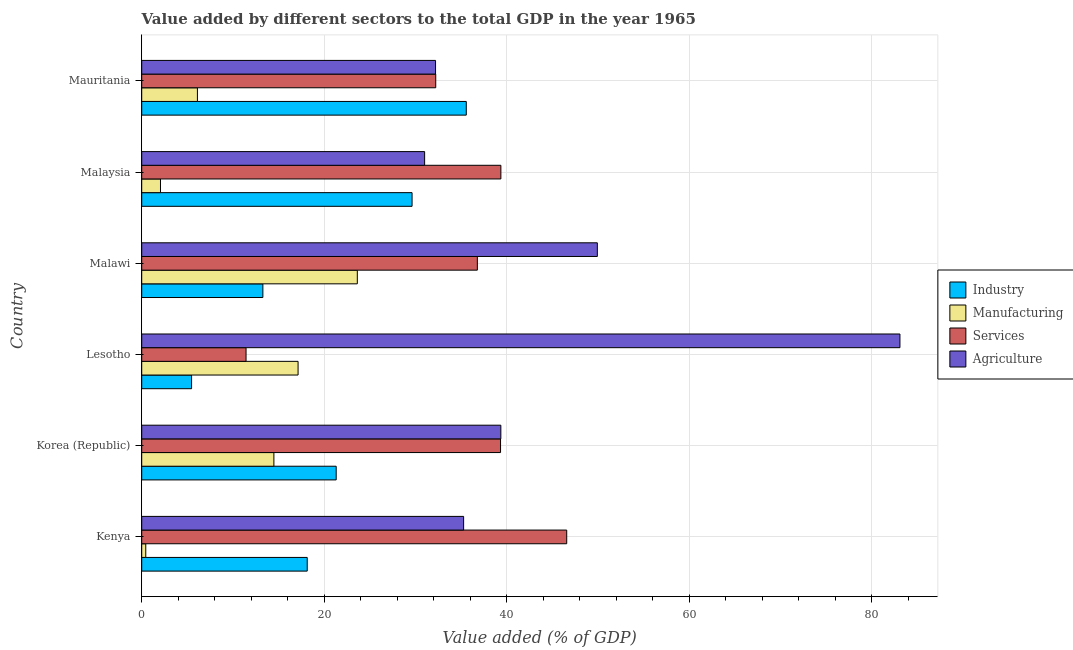How many groups of bars are there?
Offer a terse response. 6. Are the number of bars on each tick of the Y-axis equal?
Ensure brevity in your answer.  Yes. What is the label of the 5th group of bars from the top?
Keep it short and to the point. Korea (Republic). What is the value added by services sector in Mauritania?
Make the answer very short. 32.22. Across all countries, what is the maximum value added by manufacturing sector?
Provide a short and direct response. 23.63. Across all countries, what is the minimum value added by industrial sector?
Your answer should be very brief. 5.46. In which country was the value added by industrial sector maximum?
Offer a very short reply. Mauritania. In which country was the value added by agricultural sector minimum?
Give a very brief answer. Malaysia. What is the total value added by services sector in the graph?
Make the answer very short. 205.71. What is the difference between the value added by manufacturing sector in Korea (Republic) and that in Mauritania?
Give a very brief answer. 8.38. What is the difference between the value added by agricultural sector in Korea (Republic) and the value added by industrial sector in Malawi?
Ensure brevity in your answer.  26.08. What is the average value added by agricultural sector per country?
Your answer should be very brief. 45.15. What is the difference between the value added by industrial sector and value added by manufacturing sector in Malawi?
Give a very brief answer. -10.35. In how many countries, is the value added by industrial sector greater than 64 %?
Your answer should be very brief. 0. What is the ratio of the value added by services sector in Korea (Republic) to that in Lesotho?
Offer a terse response. 3.44. Is the value added by manufacturing sector in Lesotho less than that in Mauritania?
Offer a terse response. No. What is the difference between the highest and the second highest value added by manufacturing sector?
Provide a short and direct response. 6.49. What is the difference between the highest and the lowest value added by agricultural sector?
Ensure brevity in your answer.  52.1. In how many countries, is the value added by agricultural sector greater than the average value added by agricultural sector taken over all countries?
Provide a succinct answer. 2. Is it the case that in every country, the sum of the value added by agricultural sector and value added by manufacturing sector is greater than the sum of value added by industrial sector and value added by services sector?
Offer a terse response. No. What does the 3rd bar from the top in Korea (Republic) represents?
Give a very brief answer. Manufacturing. What does the 2nd bar from the bottom in Malawi represents?
Provide a succinct answer. Manufacturing. What is the difference between two consecutive major ticks on the X-axis?
Keep it short and to the point. 20. Does the graph contain grids?
Offer a very short reply. Yes. Where does the legend appear in the graph?
Provide a short and direct response. Center right. How many legend labels are there?
Keep it short and to the point. 4. How are the legend labels stacked?
Offer a very short reply. Vertical. What is the title of the graph?
Provide a succinct answer. Value added by different sectors to the total GDP in the year 1965. Does "Argument" appear as one of the legend labels in the graph?
Your answer should be very brief. No. What is the label or title of the X-axis?
Give a very brief answer. Value added (% of GDP). What is the Value added (% of GDP) of Industry in Kenya?
Make the answer very short. 18.14. What is the Value added (% of GDP) of Manufacturing in Kenya?
Give a very brief answer. 0.44. What is the Value added (% of GDP) in Services in Kenya?
Your response must be concise. 46.58. What is the Value added (% of GDP) in Agriculture in Kenya?
Keep it short and to the point. 35.28. What is the Value added (% of GDP) of Industry in Korea (Republic)?
Your answer should be very brief. 21.31. What is the Value added (% of GDP) in Manufacturing in Korea (Republic)?
Your answer should be very brief. 14.49. What is the Value added (% of GDP) in Services in Korea (Republic)?
Your response must be concise. 39.33. What is the Value added (% of GDP) of Agriculture in Korea (Republic)?
Your response must be concise. 39.36. What is the Value added (% of GDP) in Industry in Lesotho?
Provide a short and direct response. 5.46. What is the Value added (% of GDP) in Manufacturing in Lesotho?
Your answer should be compact. 17.14. What is the Value added (% of GDP) in Services in Lesotho?
Provide a short and direct response. 11.43. What is the Value added (% of GDP) of Agriculture in Lesotho?
Your answer should be very brief. 83.1. What is the Value added (% of GDP) of Industry in Malawi?
Provide a succinct answer. 13.28. What is the Value added (% of GDP) of Manufacturing in Malawi?
Provide a succinct answer. 23.63. What is the Value added (% of GDP) of Services in Malawi?
Give a very brief answer. 36.79. What is the Value added (% of GDP) in Agriculture in Malawi?
Your answer should be very brief. 49.94. What is the Value added (% of GDP) in Industry in Malaysia?
Ensure brevity in your answer.  29.63. What is the Value added (% of GDP) of Manufacturing in Malaysia?
Provide a succinct answer. 2.06. What is the Value added (% of GDP) in Services in Malaysia?
Provide a short and direct response. 39.36. What is the Value added (% of GDP) of Agriculture in Malaysia?
Provide a succinct answer. 31.01. What is the Value added (% of GDP) of Industry in Mauritania?
Your response must be concise. 35.57. What is the Value added (% of GDP) in Manufacturing in Mauritania?
Keep it short and to the point. 6.11. What is the Value added (% of GDP) in Services in Mauritania?
Your response must be concise. 32.22. What is the Value added (% of GDP) of Agriculture in Mauritania?
Your response must be concise. 32.2. Across all countries, what is the maximum Value added (% of GDP) in Industry?
Give a very brief answer. 35.57. Across all countries, what is the maximum Value added (% of GDP) in Manufacturing?
Provide a succinct answer. 23.63. Across all countries, what is the maximum Value added (% of GDP) of Services?
Your answer should be very brief. 46.58. Across all countries, what is the maximum Value added (% of GDP) in Agriculture?
Your response must be concise. 83.1. Across all countries, what is the minimum Value added (% of GDP) in Industry?
Make the answer very short. 5.46. Across all countries, what is the minimum Value added (% of GDP) in Manufacturing?
Make the answer very short. 0.44. Across all countries, what is the minimum Value added (% of GDP) of Services?
Your response must be concise. 11.43. Across all countries, what is the minimum Value added (% of GDP) of Agriculture?
Provide a succinct answer. 31.01. What is the total Value added (% of GDP) of Industry in the graph?
Give a very brief answer. 123.4. What is the total Value added (% of GDP) of Manufacturing in the graph?
Keep it short and to the point. 63.85. What is the total Value added (% of GDP) in Services in the graph?
Your answer should be very brief. 205.71. What is the total Value added (% of GDP) in Agriculture in the graph?
Your answer should be compact. 270.89. What is the difference between the Value added (% of GDP) in Industry in Kenya and that in Korea (Republic)?
Provide a succinct answer. -3.17. What is the difference between the Value added (% of GDP) in Manufacturing in Kenya and that in Korea (Republic)?
Your answer should be very brief. -14.04. What is the difference between the Value added (% of GDP) of Services in Kenya and that in Korea (Republic)?
Your response must be concise. 7.25. What is the difference between the Value added (% of GDP) of Agriculture in Kenya and that in Korea (Republic)?
Ensure brevity in your answer.  -4.08. What is the difference between the Value added (% of GDP) in Industry in Kenya and that in Lesotho?
Provide a short and direct response. 12.67. What is the difference between the Value added (% of GDP) of Manufacturing in Kenya and that in Lesotho?
Offer a very short reply. -16.69. What is the difference between the Value added (% of GDP) in Services in Kenya and that in Lesotho?
Provide a succinct answer. 35.15. What is the difference between the Value added (% of GDP) of Agriculture in Kenya and that in Lesotho?
Your answer should be compact. -47.82. What is the difference between the Value added (% of GDP) of Industry in Kenya and that in Malawi?
Your answer should be compact. 4.86. What is the difference between the Value added (% of GDP) in Manufacturing in Kenya and that in Malawi?
Make the answer very short. -23.19. What is the difference between the Value added (% of GDP) of Services in Kenya and that in Malawi?
Provide a short and direct response. 9.79. What is the difference between the Value added (% of GDP) in Agriculture in Kenya and that in Malawi?
Give a very brief answer. -14.65. What is the difference between the Value added (% of GDP) in Industry in Kenya and that in Malaysia?
Give a very brief answer. -11.49. What is the difference between the Value added (% of GDP) in Manufacturing in Kenya and that in Malaysia?
Your answer should be very brief. -1.61. What is the difference between the Value added (% of GDP) in Services in Kenya and that in Malaysia?
Give a very brief answer. 7.22. What is the difference between the Value added (% of GDP) in Agriculture in Kenya and that in Malaysia?
Provide a succinct answer. 4.27. What is the difference between the Value added (% of GDP) of Industry in Kenya and that in Mauritania?
Offer a terse response. -17.43. What is the difference between the Value added (% of GDP) in Manufacturing in Kenya and that in Mauritania?
Offer a terse response. -5.66. What is the difference between the Value added (% of GDP) in Services in Kenya and that in Mauritania?
Provide a succinct answer. 14.36. What is the difference between the Value added (% of GDP) in Agriculture in Kenya and that in Mauritania?
Keep it short and to the point. 3.08. What is the difference between the Value added (% of GDP) of Industry in Korea (Republic) and that in Lesotho?
Your response must be concise. 15.85. What is the difference between the Value added (% of GDP) in Manufacturing in Korea (Republic) and that in Lesotho?
Offer a terse response. -2.65. What is the difference between the Value added (% of GDP) of Services in Korea (Republic) and that in Lesotho?
Your answer should be very brief. 27.89. What is the difference between the Value added (% of GDP) of Agriculture in Korea (Republic) and that in Lesotho?
Ensure brevity in your answer.  -43.74. What is the difference between the Value added (% of GDP) of Industry in Korea (Republic) and that in Malawi?
Provide a succinct answer. 8.03. What is the difference between the Value added (% of GDP) in Manufacturing in Korea (Republic) and that in Malawi?
Keep it short and to the point. -9.14. What is the difference between the Value added (% of GDP) in Services in Korea (Republic) and that in Malawi?
Offer a terse response. 2.54. What is the difference between the Value added (% of GDP) in Agriculture in Korea (Republic) and that in Malawi?
Your answer should be compact. -10.58. What is the difference between the Value added (% of GDP) of Industry in Korea (Republic) and that in Malaysia?
Make the answer very short. -8.32. What is the difference between the Value added (% of GDP) of Manufacturing in Korea (Republic) and that in Malaysia?
Your answer should be compact. 12.43. What is the difference between the Value added (% of GDP) in Services in Korea (Republic) and that in Malaysia?
Your response must be concise. -0.04. What is the difference between the Value added (% of GDP) of Agriculture in Korea (Republic) and that in Malaysia?
Offer a terse response. 8.35. What is the difference between the Value added (% of GDP) in Industry in Korea (Republic) and that in Mauritania?
Give a very brief answer. -14.26. What is the difference between the Value added (% of GDP) of Manufacturing in Korea (Republic) and that in Mauritania?
Provide a succinct answer. 8.38. What is the difference between the Value added (% of GDP) of Services in Korea (Republic) and that in Mauritania?
Ensure brevity in your answer.  7.1. What is the difference between the Value added (% of GDP) in Agriculture in Korea (Republic) and that in Mauritania?
Offer a terse response. 7.16. What is the difference between the Value added (% of GDP) in Industry in Lesotho and that in Malawi?
Your response must be concise. -7.81. What is the difference between the Value added (% of GDP) of Manufacturing in Lesotho and that in Malawi?
Make the answer very short. -6.49. What is the difference between the Value added (% of GDP) of Services in Lesotho and that in Malawi?
Your answer should be compact. -25.35. What is the difference between the Value added (% of GDP) in Agriculture in Lesotho and that in Malawi?
Keep it short and to the point. 33.17. What is the difference between the Value added (% of GDP) in Industry in Lesotho and that in Malaysia?
Keep it short and to the point. -24.17. What is the difference between the Value added (% of GDP) of Manufacturing in Lesotho and that in Malaysia?
Provide a succinct answer. 15.08. What is the difference between the Value added (% of GDP) of Services in Lesotho and that in Malaysia?
Provide a short and direct response. -27.93. What is the difference between the Value added (% of GDP) in Agriculture in Lesotho and that in Malaysia?
Your answer should be compact. 52.1. What is the difference between the Value added (% of GDP) of Industry in Lesotho and that in Mauritania?
Offer a very short reply. -30.11. What is the difference between the Value added (% of GDP) of Manufacturing in Lesotho and that in Mauritania?
Provide a succinct answer. 11.03. What is the difference between the Value added (% of GDP) in Services in Lesotho and that in Mauritania?
Keep it short and to the point. -20.79. What is the difference between the Value added (% of GDP) of Agriculture in Lesotho and that in Mauritania?
Make the answer very short. 50.9. What is the difference between the Value added (% of GDP) in Industry in Malawi and that in Malaysia?
Give a very brief answer. -16.35. What is the difference between the Value added (% of GDP) of Manufacturing in Malawi and that in Malaysia?
Ensure brevity in your answer.  21.57. What is the difference between the Value added (% of GDP) of Services in Malawi and that in Malaysia?
Make the answer very short. -2.58. What is the difference between the Value added (% of GDP) in Agriculture in Malawi and that in Malaysia?
Provide a succinct answer. 18.93. What is the difference between the Value added (% of GDP) in Industry in Malawi and that in Mauritania?
Keep it short and to the point. -22.29. What is the difference between the Value added (% of GDP) in Manufacturing in Malawi and that in Mauritania?
Your answer should be very brief. 17.52. What is the difference between the Value added (% of GDP) in Services in Malawi and that in Mauritania?
Give a very brief answer. 4.56. What is the difference between the Value added (% of GDP) in Agriculture in Malawi and that in Mauritania?
Ensure brevity in your answer.  17.73. What is the difference between the Value added (% of GDP) of Industry in Malaysia and that in Mauritania?
Ensure brevity in your answer.  -5.94. What is the difference between the Value added (% of GDP) of Manufacturing in Malaysia and that in Mauritania?
Provide a succinct answer. -4.05. What is the difference between the Value added (% of GDP) in Services in Malaysia and that in Mauritania?
Ensure brevity in your answer.  7.14. What is the difference between the Value added (% of GDP) in Agriculture in Malaysia and that in Mauritania?
Provide a short and direct response. -1.2. What is the difference between the Value added (% of GDP) of Industry in Kenya and the Value added (% of GDP) of Manufacturing in Korea (Republic)?
Provide a succinct answer. 3.65. What is the difference between the Value added (% of GDP) of Industry in Kenya and the Value added (% of GDP) of Services in Korea (Republic)?
Provide a succinct answer. -21.19. What is the difference between the Value added (% of GDP) of Industry in Kenya and the Value added (% of GDP) of Agriculture in Korea (Republic)?
Your response must be concise. -21.22. What is the difference between the Value added (% of GDP) in Manufacturing in Kenya and the Value added (% of GDP) in Services in Korea (Republic)?
Offer a very short reply. -38.88. What is the difference between the Value added (% of GDP) of Manufacturing in Kenya and the Value added (% of GDP) of Agriculture in Korea (Republic)?
Keep it short and to the point. -38.92. What is the difference between the Value added (% of GDP) of Services in Kenya and the Value added (% of GDP) of Agriculture in Korea (Republic)?
Provide a short and direct response. 7.22. What is the difference between the Value added (% of GDP) of Industry in Kenya and the Value added (% of GDP) of Services in Lesotho?
Provide a succinct answer. 6.7. What is the difference between the Value added (% of GDP) in Industry in Kenya and the Value added (% of GDP) in Agriculture in Lesotho?
Provide a succinct answer. -64.96. What is the difference between the Value added (% of GDP) of Manufacturing in Kenya and the Value added (% of GDP) of Services in Lesotho?
Your response must be concise. -10.99. What is the difference between the Value added (% of GDP) of Manufacturing in Kenya and the Value added (% of GDP) of Agriculture in Lesotho?
Provide a succinct answer. -82.66. What is the difference between the Value added (% of GDP) in Services in Kenya and the Value added (% of GDP) in Agriculture in Lesotho?
Your answer should be compact. -36.52. What is the difference between the Value added (% of GDP) of Industry in Kenya and the Value added (% of GDP) of Manufacturing in Malawi?
Your answer should be very brief. -5.49. What is the difference between the Value added (% of GDP) in Industry in Kenya and the Value added (% of GDP) in Services in Malawi?
Provide a succinct answer. -18.65. What is the difference between the Value added (% of GDP) of Industry in Kenya and the Value added (% of GDP) of Agriculture in Malawi?
Offer a very short reply. -31.8. What is the difference between the Value added (% of GDP) in Manufacturing in Kenya and the Value added (% of GDP) in Services in Malawi?
Provide a short and direct response. -36.34. What is the difference between the Value added (% of GDP) of Manufacturing in Kenya and the Value added (% of GDP) of Agriculture in Malawi?
Make the answer very short. -49.49. What is the difference between the Value added (% of GDP) of Services in Kenya and the Value added (% of GDP) of Agriculture in Malawi?
Provide a succinct answer. -3.36. What is the difference between the Value added (% of GDP) in Industry in Kenya and the Value added (% of GDP) in Manufacturing in Malaysia?
Give a very brief answer. 16.08. What is the difference between the Value added (% of GDP) in Industry in Kenya and the Value added (% of GDP) in Services in Malaysia?
Offer a very short reply. -21.23. What is the difference between the Value added (% of GDP) of Industry in Kenya and the Value added (% of GDP) of Agriculture in Malaysia?
Give a very brief answer. -12.87. What is the difference between the Value added (% of GDP) of Manufacturing in Kenya and the Value added (% of GDP) of Services in Malaysia?
Offer a terse response. -38.92. What is the difference between the Value added (% of GDP) in Manufacturing in Kenya and the Value added (% of GDP) in Agriculture in Malaysia?
Offer a very short reply. -30.56. What is the difference between the Value added (% of GDP) of Services in Kenya and the Value added (% of GDP) of Agriculture in Malaysia?
Provide a succinct answer. 15.57. What is the difference between the Value added (% of GDP) of Industry in Kenya and the Value added (% of GDP) of Manufacturing in Mauritania?
Your response must be concise. 12.03. What is the difference between the Value added (% of GDP) in Industry in Kenya and the Value added (% of GDP) in Services in Mauritania?
Ensure brevity in your answer.  -14.09. What is the difference between the Value added (% of GDP) in Industry in Kenya and the Value added (% of GDP) in Agriculture in Mauritania?
Provide a succinct answer. -14.06. What is the difference between the Value added (% of GDP) of Manufacturing in Kenya and the Value added (% of GDP) of Services in Mauritania?
Offer a very short reply. -31.78. What is the difference between the Value added (% of GDP) of Manufacturing in Kenya and the Value added (% of GDP) of Agriculture in Mauritania?
Your response must be concise. -31.76. What is the difference between the Value added (% of GDP) of Services in Kenya and the Value added (% of GDP) of Agriculture in Mauritania?
Provide a succinct answer. 14.38. What is the difference between the Value added (% of GDP) in Industry in Korea (Republic) and the Value added (% of GDP) in Manufacturing in Lesotho?
Provide a short and direct response. 4.18. What is the difference between the Value added (% of GDP) in Industry in Korea (Republic) and the Value added (% of GDP) in Services in Lesotho?
Provide a short and direct response. 9.88. What is the difference between the Value added (% of GDP) in Industry in Korea (Republic) and the Value added (% of GDP) in Agriculture in Lesotho?
Provide a succinct answer. -61.79. What is the difference between the Value added (% of GDP) in Manufacturing in Korea (Republic) and the Value added (% of GDP) in Services in Lesotho?
Make the answer very short. 3.05. What is the difference between the Value added (% of GDP) of Manufacturing in Korea (Republic) and the Value added (% of GDP) of Agriculture in Lesotho?
Provide a short and direct response. -68.62. What is the difference between the Value added (% of GDP) of Services in Korea (Republic) and the Value added (% of GDP) of Agriculture in Lesotho?
Your response must be concise. -43.77. What is the difference between the Value added (% of GDP) of Industry in Korea (Republic) and the Value added (% of GDP) of Manufacturing in Malawi?
Offer a terse response. -2.32. What is the difference between the Value added (% of GDP) in Industry in Korea (Republic) and the Value added (% of GDP) in Services in Malawi?
Make the answer very short. -15.47. What is the difference between the Value added (% of GDP) in Industry in Korea (Republic) and the Value added (% of GDP) in Agriculture in Malawi?
Ensure brevity in your answer.  -28.62. What is the difference between the Value added (% of GDP) in Manufacturing in Korea (Republic) and the Value added (% of GDP) in Services in Malawi?
Your answer should be very brief. -22.3. What is the difference between the Value added (% of GDP) of Manufacturing in Korea (Republic) and the Value added (% of GDP) of Agriculture in Malawi?
Provide a short and direct response. -35.45. What is the difference between the Value added (% of GDP) in Services in Korea (Republic) and the Value added (% of GDP) in Agriculture in Malawi?
Provide a succinct answer. -10.61. What is the difference between the Value added (% of GDP) in Industry in Korea (Republic) and the Value added (% of GDP) in Manufacturing in Malaysia?
Ensure brevity in your answer.  19.26. What is the difference between the Value added (% of GDP) in Industry in Korea (Republic) and the Value added (% of GDP) in Services in Malaysia?
Your answer should be very brief. -18.05. What is the difference between the Value added (% of GDP) of Industry in Korea (Republic) and the Value added (% of GDP) of Agriculture in Malaysia?
Provide a succinct answer. -9.69. What is the difference between the Value added (% of GDP) of Manufacturing in Korea (Republic) and the Value added (% of GDP) of Services in Malaysia?
Your response must be concise. -24.88. What is the difference between the Value added (% of GDP) in Manufacturing in Korea (Republic) and the Value added (% of GDP) in Agriculture in Malaysia?
Make the answer very short. -16.52. What is the difference between the Value added (% of GDP) in Services in Korea (Republic) and the Value added (% of GDP) in Agriculture in Malaysia?
Ensure brevity in your answer.  8.32. What is the difference between the Value added (% of GDP) of Industry in Korea (Republic) and the Value added (% of GDP) of Manufacturing in Mauritania?
Ensure brevity in your answer.  15.21. What is the difference between the Value added (% of GDP) of Industry in Korea (Republic) and the Value added (% of GDP) of Services in Mauritania?
Your answer should be compact. -10.91. What is the difference between the Value added (% of GDP) of Industry in Korea (Republic) and the Value added (% of GDP) of Agriculture in Mauritania?
Give a very brief answer. -10.89. What is the difference between the Value added (% of GDP) of Manufacturing in Korea (Republic) and the Value added (% of GDP) of Services in Mauritania?
Offer a terse response. -17.74. What is the difference between the Value added (% of GDP) of Manufacturing in Korea (Republic) and the Value added (% of GDP) of Agriculture in Mauritania?
Offer a very short reply. -17.72. What is the difference between the Value added (% of GDP) of Services in Korea (Republic) and the Value added (% of GDP) of Agriculture in Mauritania?
Your answer should be very brief. 7.12. What is the difference between the Value added (% of GDP) in Industry in Lesotho and the Value added (% of GDP) in Manufacturing in Malawi?
Ensure brevity in your answer.  -18.16. What is the difference between the Value added (% of GDP) of Industry in Lesotho and the Value added (% of GDP) of Services in Malawi?
Provide a short and direct response. -31.32. What is the difference between the Value added (% of GDP) of Industry in Lesotho and the Value added (% of GDP) of Agriculture in Malawi?
Provide a short and direct response. -44.47. What is the difference between the Value added (% of GDP) of Manufacturing in Lesotho and the Value added (% of GDP) of Services in Malawi?
Offer a terse response. -19.65. What is the difference between the Value added (% of GDP) in Manufacturing in Lesotho and the Value added (% of GDP) in Agriculture in Malawi?
Provide a short and direct response. -32.8. What is the difference between the Value added (% of GDP) in Services in Lesotho and the Value added (% of GDP) in Agriculture in Malawi?
Provide a short and direct response. -38.5. What is the difference between the Value added (% of GDP) of Industry in Lesotho and the Value added (% of GDP) of Manufacturing in Malaysia?
Provide a short and direct response. 3.41. What is the difference between the Value added (% of GDP) in Industry in Lesotho and the Value added (% of GDP) in Services in Malaysia?
Ensure brevity in your answer.  -33.9. What is the difference between the Value added (% of GDP) in Industry in Lesotho and the Value added (% of GDP) in Agriculture in Malaysia?
Ensure brevity in your answer.  -25.54. What is the difference between the Value added (% of GDP) in Manufacturing in Lesotho and the Value added (% of GDP) in Services in Malaysia?
Keep it short and to the point. -22.23. What is the difference between the Value added (% of GDP) of Manufacturing in Lesotho and the Value added (% of GDP) of Agriculture in Malaysia?
Give a very brief answer. -13.87. What is the difference between the Value added (% of GDP) of Services in Lesotho and the Value added (% of GDP) of Agriculture in Malaysia?
Keep it short and to the point. -19.57. What is the difference between the Value added (% of GDP) of Industry in Lesotho and the Value added (% of GDP) of Manufacturing in Mauritania?
Your response must be concise. -0.64. What is the difference between the Value added (% of GDP) in Industry in Lesotho and the Value added (% of GDP) in Services in Mauritania?
Your answer should be compact. -26.76. What is the difference between the Value added (% of GDP) of Industry in Lesotho and the Value added (% of GDP) of Agriculture in Mauritania?
Your answer should be very brief. -26.74. What is the difference between the Value added (% of GDP) in Manufacturing in Lesotho and the Value added (% of GDP) in Services in Mauritania?
Offer a terse response. -15.09. What is the difference between the Value added (% of GDP) in Manufacturing in Lesotho and the Value added (% of GDP) in Agriculture in Mauritania?
Offer a terse response. -15.07. What is the difference between the Value added (% of GDP) in Services in Lesotho and the Value added (% of GDP) in Agriculture in Mauritania?
Your answer should be very brief. -20.77. What is the difference between the Value added (% of GDP) of Industry in Malawi and the Value added (% of GDP) of Manufacturing in Malaysia?
Your response must be concise. 11.22. What is the difference between the Value added (% of GDP) in Industry in Malawi and the Value added (% of GDP) in Services in Malaysia?
Your answer should be compact. -26.09. What is the difference between the Value added (% of GDP) in Industry in Malawi and the Value added (% of GDP) in Agriculture in Malaysia?
Give a very brief answer. -17.73. What is the difference between the Value added (% of GDP) in Manufacturing in Malawi and the Value added (% of GDP) in Services in Malaysia?
Provide a short and direct response. -15.74. What is the difference between the Value added (% of GDP) of Manufacturing in Malawi and the Value added (% of GDP) of Agriculture in Malaysia?
Offer a terse response. -7.38. What is the difference between the Value added (% of GDP) in Services in Malawi and the Value added (% of GDP) in Agriculture in Malaysia?
Provide a short and direct response. 5.78. What is the difference between the Value added (% of GDP) in Industry in Malawi and the Value added (% of GDP) in Manufacturing in Mauritania?
Make the answer very short. 7.17. What is the difference between the Value added (% of GDP) of Industry in Malawi and the Value added (% of GDP) of Services in Mauritania?
Your answer should be compact. -18.95. What is the difference between the Value added (% of GDP) of Industry in Malawi and the Value added (% of GDP) of Agriculture in Mauritania?
Offer a very short reply. -18.93. What is the difference between the Value added (% of GDP) in Manufacturing in Malawi and the Value added (% of GDP) in Services in Mauritania?
Make the answer very short. -8.6. What is the difference between the Value added (% of GDP) of Manufacturing in Malawi and the Value added (% of GDP) of Agriculture in Mauritania?
Your answer should be very brief. -8.58. What is the difference between the Value added (% of GDP) of Services in Malawi and the Value added (% of GDP) of Agriculture in Mauritania?
Offer a very short reply. 4.58. What is the difference between the Value added (% of GDP) of Industry in Malaysia and the Value added (% of GDP) of Manufacturing in Mauritania?
Your answer should be very brief. 23.52. What is the difference between the Value added (% of GDP) in Industry in Malaysia and the Value added (% of GDP) in Services in Mauritania?
Provide a short and direct response. -2.59. What is the difference between the Value added (% of GDP) of Industry in Malaysia and the Value added (% of GDP) of Agriculture in Mauritania?
Make the answer very short. -2.57. What is the difference between the Value added (% of GDP) in Manufacturing in Malaysia and the Value added (% of GDP) in Services in Mauritania?
Provide a succinct answer. -30.17. What is the difference between the Value added (% of GDP) in Manufacturing in Malaysia and the Value added (% of GDP) in Agriculture in Mauritania?
Ensure brevity in your answer.  -30.15. What is the difference between the Value added (% of GDP) of Services in Malaysia and the Value added (% of GDP) of Agriculture in Mauritania?
Offer a terse response. 7.16. What is the average Value added (% of GDP) of Industry per country?
Your answer should be very brief. 20.57. What is the average Value added (% of GDP) in Manufacturing per country?
Offer a terse response. 10.64. What is the average Value added (% of GDP) of Services per country?
Your answer should be compact. 34.29. What is the average Value added (% of GDP) of Agriculture per country?
Your answer should be compact. 45.15. What is the difference between the Value added (% of GDP) in Industry and Value added (% of GDP) in Manufacturing in Kenya?
Make the answer very short. 17.7. What is the difference between the Value added (% of GDP) in Industry and Value added (% of GDP) in Services in Kenya?
Offer a terse response. -28.44. What is the difference between the Value added (% of GDP) in Industry and Value added (% of GDP) in Agriculture in Kenya?
Keep it short and to the point. -17.14. What is the difference between the Value added (% of GDP) in Manufacturing and Value added (% of GDP) in Services in Kenya?
Offer a terse response. -46.14. What is the difference between the Value added (% of GDP) of Manufacturing and Value added (% of GDP) of Agriculture in Kenya?
Your answer should be compact. -34.84. What is the difference between the Value added (% of GDP) in Services and Value added (% of GDP) in Agriculture in Kenya?
Your answer should be compact. 11.3. What is the difference between the Value added (% of GDP) in Industry and Value added (% of GDP) in Manufacturing in Korea (Republic)?
Your answer should be very brief. 6.83. What is the difference between the Value added (% of GDP) of Industry and Value added (% of GDP) of Services in Korea (Republic)?
Offer a very short reply. -18.01. What is the difference between the Value added (% of GDP) in Industry and Value added (% of GDP) in Agriculture in Korea (Republic)?
Offer a terse response. -18.05. What is the difference between the Value added (% of GDP) of Manufacturing and Value added (% of GDP) of Services in Korea (Republic)?
Your answer should be very brief. -24.84. What is the difference between the Value added (% of GDP) of Manufacturing and Value added (% of GDP) of Agriculture in Korea (Republic)?
Make the answer very short. -24.87. What is the difference between the Value added (% of GDP) of Services and Value added (% of GDP) of Agriculture in Korea (Republic)?
Offer a terse response. -0.03. What is the difference between the Value added (% of GDP) in Industry and Value added (% of GDP) in Manufacturing in Lesotho?
Keep it short and to the point. -11.67. What is the difference between the Value added (% of GDP) in Industry and Value added (% of GDP) in Services in Lesotho?
Provide a succinct answer. -5.97. What is the difference between the Value added (% of GDP) in Industry and Value added (% of GDP) in Agriculture in Lesotho?
Your answer should be very brief. -77.64. What is the difference between the Value added (% of GDP) of Manufacturing and Value added (% of GDP) of Services in Lesotho?
Provide a short and direct response. 5.7. What is the difference between the Value added (% of GDP) of Manufacturing and Value added (% of GDP) of Agriculture in Lesotho?
Your answer should be very brief. -65.97. What is the difference between the Value added (% of GDP) of Services and Value added (% of GDP) of Agriculture in Lesotho?
Your answer should be very brief. -71.67. What is the difference between the Value added (% of GDP) of Industry and Value added (% of GDP) of Manufacturing in Malawi?
Offer a very short reply. -10.35. What is the difference between the Value added (% of GDP) of Industry and Value added (% of GDP) of Services in Malawi?
Your answer should be compact. -23.51. What is the difference between the Value added (% of GDP) of Industry and Value added (% of GDP) of Agriculture in Malawi?
Keep it short and to the point. -36.66. What is the difference between the Value added (% of GDP) in Manufacturing and Value added (% of GDP) in Services in Malawi?
Offer a terse response. -13.16. What is the difference between the Value added (% of GDP) of Manufacturing and Value added (% of GDP) of Agriculture in Malawi?
Keep it short and to the point. -26.31. What is the difference between the Value added (% of GDP) in Services and Value added (% of GDP) in Agriculture in Malawi?
Your response must be concise. -13.15. What is the difference between the Value added (% of GDP) in Industry and Value added (% of GDP) in Manufacturing in Malaysia?
Your answer should be very brief. 27.57. What is the difference between the Value added (% of GDP) in Industry and Value added (% of GDP) in Services in Malaysia?
Your response must be concise. -9.73. What is the difference between the Value added (% of GDP) in Industry and Value added (% of GDP) in Agriculture in Malaysia?
Provide a succinct answer. -1.38. What is the difference between the Value added (% of GDP) in Manufacturing and Value added (% of GDP) in Services in Malaysia?
Give a very brief answer. -37.31. What is the difference between the Value added (% of GDP) of Manufacturing and Value added (% of GDP) of Agriculture in Malaysia?
Ensure brevity in your answer.  -28.95. What is the difference between the Value added (% of GDP) in Services and Value added (% of GDP) in Agriculture in Malaysia?
Your answer should be very brief. 8.36. What is the difference between the Value added (% of GDP) in Industry and Value added (% of GDP) in Manufacturing in Mauritania?
Provide a succinct answer. 29.47. What is the difference between the Value added (% of GDP) of Industry and Value added (% of GDP) of Services in Mauritania?
Your answer should be very brief. 3.35. What is the difference between the Value added (% of GDP) in Industry and Value added (% of GDP) in Agriculture in Mauritania?
Provide a succinct answer. 3.37. What is the difference between the Value added (% of GDP) in Manufacturing and Value added (% of GDP) in Services in Mauritania?
Give a very brief answer. -26.12. What is the difference between the Value added (% of GDP) of Manufacturing and Value added (% of GDP) of Agriculture in Mauritania?
Provide a succinct answer. -26.1. What is the difference between the Value added (% of GDP) of Services and Value added (% of GDP) of Agriculture in Mauritania?
Your response must be concise. 0.02. What is the ratio of the Value added (% of GDP) in Industry in Kenya to that in Korea (Republic)?
Provide a succinct answer. 0.85. What is the ratio of the Value added (% of GDP) in Manufacturing in Kenya to that in Korea (Republic)?
Provide a succinct answer. 0.03. What is the ratio of the Value added (% of GDP) of Services in Kenya to that in Korea (Republic)?
Provide a succinct answer. 1.18. What is the ratio of the Value added (% of GDP) in Agriculture in Kenya to that in Korea (Republic)?
Provide a succinct answer. 0.9. What is the ratio of the Value added (% of GDP) of Industry in Kenya to that in Lesotho?
Your response must be concise. 3.32. What is the ratio of the Value added (% of GDP) in Manufacturing in Kenya to that in Lesotho?
Your answer should be very brief. 0.03. What is the ratio of the Value added (% of GDP) of Services in Kenya to that in Lesotho?
Offer a terse response. 4.07. What is the ratio of the Value added (% of GDP) of Agriculture in Kenya to that in Lesotho?
Offer a very short reply. 0.42. What is the ratio of the Value added (% of GDP) in Industry in Kenya to that in Malawi?
Your answer should be very brief. 1.37. What is the ratio of the Value added (% of GDP) in Manufacturing in Kenya to that in Malawi?
Your answer should be compact. 0.02. What is the ratio of the Value added (% of GDP) of Services in Kenya to that in Malawi?
Your answer should be compact. 1.27. What is the ratio of the Value added (% of GDP) in Agriculture in Kenya to that in Malawi?
Your answer should be very brief. 0.71. What is the ratio of the Value added (% of GDP) of Industry in Kenya to that in Malaysia?
Make the answer very short. 0.61. What is the ratio of the Value added (% of GDP) of Manufacturing in Kenya to that in Malaysia?
Ensure brevity in your answer.  0.22. What is the ratio of the Value added (% of GDP) in Services in Kenya to that in Malaysia?
Provide a short and direct response. 1.18. What is the ratio of the Value added (% of GDP) of Agriculture in Kenya to that in Malaysia?
Ensure brevity in your answer.  1.14. What is the ratio of the Value added (% of GDP) of Industry in Kenya to that in Mauritania?
Offer a terse response. 0.51. What is the ratio of the Value added (% of GDP) of Manufacturing in Kenya to that in Mauritania?
Make the answer very short. 0.07. What is the ratio of the Value added (% of GDP) in Services in Kenya to that in Mauritania?
Ensure brevity in your answer.  1.45. What is the ratio of the Value added (% of GDP) in Agriculture in Kenya to that in Mauritania?
Make the answer very short. 1.1. What is the ratio of the Value added (% of GDP) of Industry in Korea (Republic) to that in Lesotho?
Make the answer very short. 3.9. What is the ratio of the Value added (% of GDP) in Manufacturing in Korea (Republic) to that in Lesotho?
Your response must be concise. 0.85. What is the ratio of the Value added (% of GDP) in Services in Korea (Republic) to that in Lesotho?
Make the answer very short. 3.44. What is the ratio of the Value added (% of GDP) in Agriculture in Korea (Republic) to that in Lesotho?
Keep it short and to the point. 0.47. What is the ratio of the Value added (% of GDP) of Industry in Korea (Republic) to that in Malawi?
Make the answer very short. 1.61. What is the ratio of the Value added (% of GDP) of Manufacturing in Korea (Republic) to that in Malawi?
Keep it short and to the point. 0.61. What is the ratio of the Value added (% of GDP) in Services in Korea (Republic) to that in Malawi?
Provide a succinct answer. 1.07. What is the ratio of the Value added (% of GDP) in Agriculture in Korea (Republic) to that in Malawi?
Provide a succinct answer. 0.79. What is the ratio of the Value added (% of GDP) of Industry in Korea (Republic) to that in Malaysia?
Provide a short and direct response. 0.72. What is the ratio of the Value added (% of GDP) in Manufacturing in Korea (Republic) to that in Malaysia?
Keep it short and to the point. 7.04. What is the ratio of the Value added (% of GDP) of Agriculture in Korea (Republic) to that in Malaysia?
Your answer should be very brief. 1.27. What is the ratio of the Value added (% of GDP) of Industry in Korea (Republic) to that in Mauritania?
Provide a short and direct response. 0.6. What is the ratio of the Value added (% of GDP) in Manufacturing in Korea (Republic) to that in Mauritania?
Your response must be concise. 2.37. What is the ratio of the Value added (% of GDP) in Services in Korea (Republic) to that in Mauritania?
Your response must be concise. 1.22. What is the ratio of the Value added (% of GDP) in Agriculture in Korea (Republic) to that in Mauritania?
Ensure brevity in your answer.  1.22. What is the ratio of the Value added (% of GDP) in Industry in Lesotho to that in Malawi?
Your response must be concise. 0.41. What is the ratio of the Value added (% of GDP) in Manufacturing in Lesotho to that in Malawi?
Your answer should be very brief. 0.73. What is the ratio of the Value added (% of GDP) of Services in Lesotho to that in Malawi?
Keep it short and to the point. 0.31. What is the ratio of the Value added (% of GDP) of Agriculture in Lesotho to that in Malawi?
Your response must be concise. 1.66. What is the ratio of the Value added (% of GDP) of Industry in Lesotho to that in Malaysia?
Give a very brief answer. 0.18. What is the ratio of the Value added (% of GDP) of Manufacturing in Lesotho to that in Malaysia?
Provide a short and direct response. 8.33. What is the ratio of the Value added (% of GDP) in Services in Lesotho to that in Malaysia?
Your answer should be compact. 0.29. What is the ratio of the Value added (% of GDP) of Agriculture in Lesotho to that in Malaysia?
Keep it short and to the point. 2.68. What is the ratio of the Value added (% of GDP) in Industry in Lesotho to that in Mauritania?
Keep it short and to the point. 0.15. What is the ratio of the Value added (% of GDP) in Manufacturing in Lesotho to that in Mauritania?
Make the answer very short. 2.81. What is the ratio of the Value added (% of GDP) in Services in Lesotho to that in Mauritania?
Ensure brevity in your answer.  0.35. What is the ratio of the Value added (% of GDP) in Agriculture in Lesotho to that in Mauritania?
Offer a terse response. 2.58. What is the ratio of the Value added (% of GDP) in Industry in Malawi to that in Malaysia?
Offer a very short reply. 0.45. What is the ratio of the Value added (% of GDP) in Manufacturing in Malawi to that in Malaysia?
Offer a terse response. 11.49. What is the ratio of the Value added (% of GDP) of Services in Malawi to that in Malaysia?
Offer a very short reply. 0.93. What is the ratio of the Value added (% of GDP) in Agriculture in Malawi to that in Malaysia?
Provide a succinct answer. 1.61. What is the ratio of the Value added (% of GDP) of Industry in Malawi to that in Mauritania?
Give a very brief answer. 0.37. What is the ratio of the Value added (% of GDP) of Manufacturing in Malawi to that in Mauritania?
Your response must be concise. 3.87. What is the ratio of the Value added (% of GDP) in Services in Malawi to that in Mauritania?
Make the answer very short. 1.14. What is the ratio of the Value added (% of GDP) of Agriculture in Malawi to that in Mauritania?
Offer a very short reply. 1.55. What is the ratio of the Value added (% of GDP) in Industry in Malaysia to that in Mauritania?
Ensure brevity in your answer.  0.83. What is the ratio of the Value added (% of GDP) in Manufacturing in Malaysia to that in Mauritania?
Your answer should be compact. 0.34. What is the ratio of the Value added (% of GDP) of Services in Malaysia to that in Mauritania?
Offer a terse response. 1.22. What is the ratio of the Value added (% of GDP) of Agriculture in Malaysia to that in Mauritania?
Ensure brevity in your answer.  0.96. What is the difference between the highest and the second highest Value added (% of GDP) in Industry?
Your response must be concise. 5.94. What is the difference between the highest and the second highest Value added (% of GDP) in Manufacturing?
Provide a succinct answer. 6.49. What is the difference between the highest and the second highest Value added (% of GDP) of Services?
Give a very brief answer. 7.22. What is the difference between the highest and the second highest Value added (% of GDP) in Agriculture?
Keep it short and to the point. 33.17. What is the difference between the highest and the lowest Value added (% of GDP) of Industry?
Give a very brief answer. 30.11. What is the difference between the highest and the lowest Value added (% of GDP) of Manufacturing?
Provide a short and direct response. 23.19. What is the difference between the highest and the lowest Value added (% of GDP) in Services?
Your answer should be very brief. 35.15. What is the difference between the highest and the lowest Value added (% of GDP) of Agriculture?
Your answer should be very brief. 52.1. 